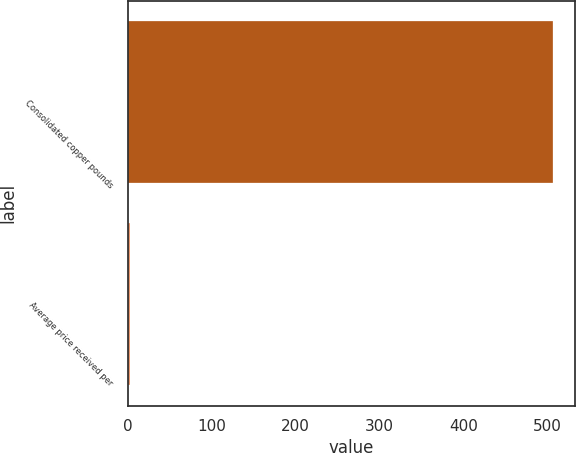Convert chart. <chart><loc_0><loc_0><loc_500><loc_500><bar_chart><fcel>Consolidated copper pounds<fcel>Average price received per<nl><fcel>507<fcel>2.6<nl></chart> 